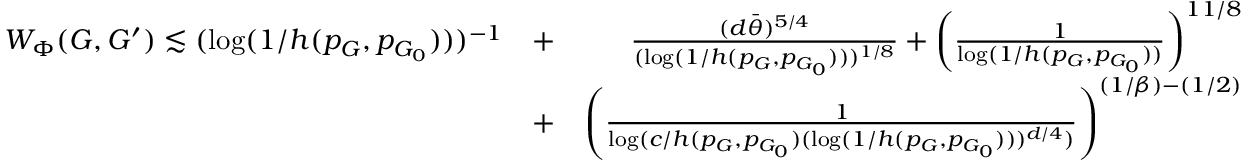Convert formula to latex. <formula><loc_0><loc_0><loc_500><loc_500>\begin{array} { r l r } { W _ { \Phi } ( G , G ^ { \prime } ) \lesssim ( \log ( 1 / h ( p _ { G } , p _ { G _ { 0 } } ) ) ) ^ { - 1 } } & { + } & { \frac { ( d \bar { \theta } ) ^ { 5 / 4 } } { ( \log ( 1 / h ( p _ { G } , p _ { G _ { 0 } } ) ) ) ^ { 1 / 8 } } + \left ( \frac { 1 } { \log ( 1 / h ( p _ { G } , p _ { G _ { 0 } } ) ) } \right ) ^ { 1 1 / 8 } } \\ & { + } & { \left ( \frac { 1 } { \log ( c / h ( p _ { G } , p _ { G _ { 0 } } ) ( \log ( 1 / h ( p _ { G } , p _ { G _ { 0 } } ) ) ) ^ { d / 4 } ) } \right ) ^ { ( 1 / \beta ) - ( 1 / 2 ) } } \end{array}</formula> 